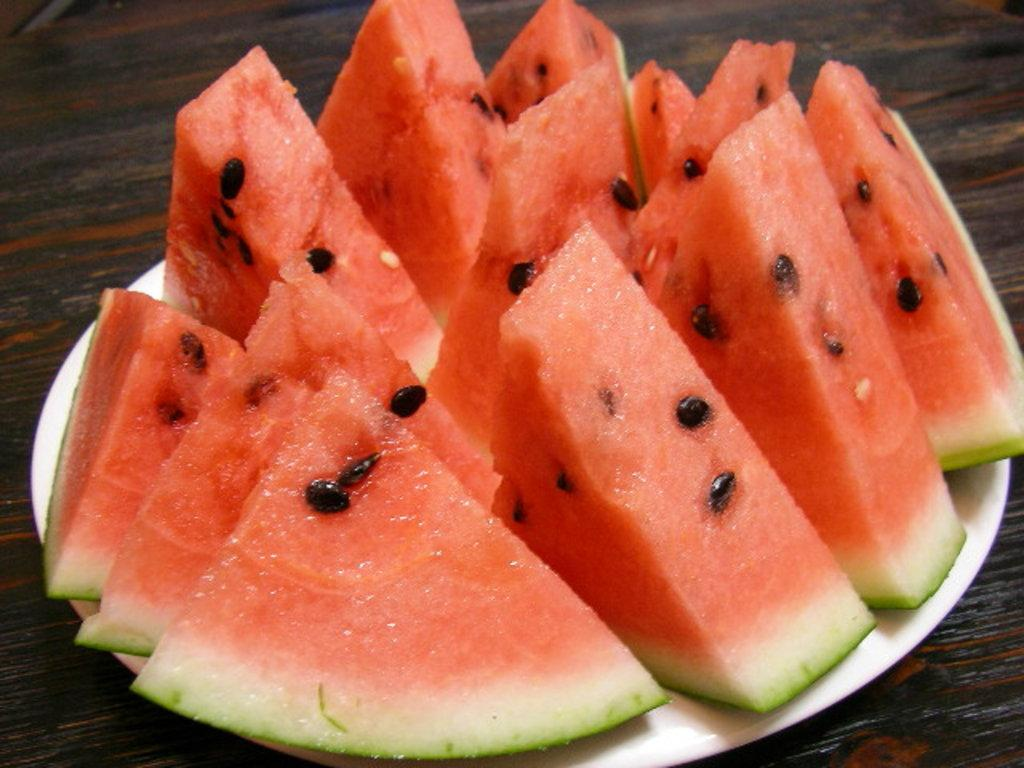What type of food is visible in the image? The image contains watermelon slices. What is the plate made of, and what color is it? The plate is white. Where is the plate located in the image? The plate is on a desk. What type of snail can be seen crawling on the watermelon slices in the image? There is no snail present in the image; it only contains watermelon slices and a white plate on a desk. 